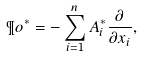Convert formula to latex. <formula><loc_0><loc_0><loc_500><loc_500>\P o ^ { * } = - \sum _ { i = 1 } ^ { n } A ^ { * } _ { i } \frac { \partial } { \partial x _ { i } } ,</formula> 